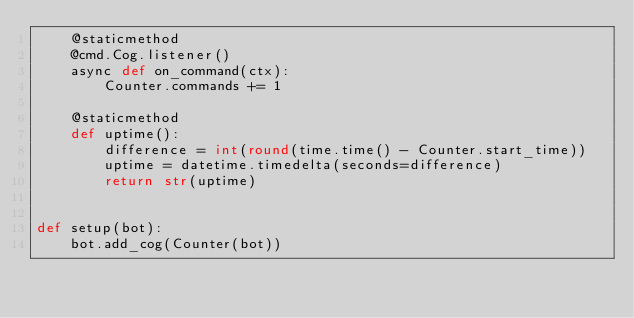<code> <loc_0><loc_0><loc_500><loc_500><_Python_>    @staticmethod
    @cmd.Cog.listener()
    async def on_command(ctx):
        Counter.commands += 1

    @staticmethod
    def uptime():
        difference = int(round(time.time() - Counter.start_time))
        uptime = datetime.timedelta(seconds=difference)
        return str(uptime)


def setup(bot):
    bot.add_cog(Counter(bot))
</code> 